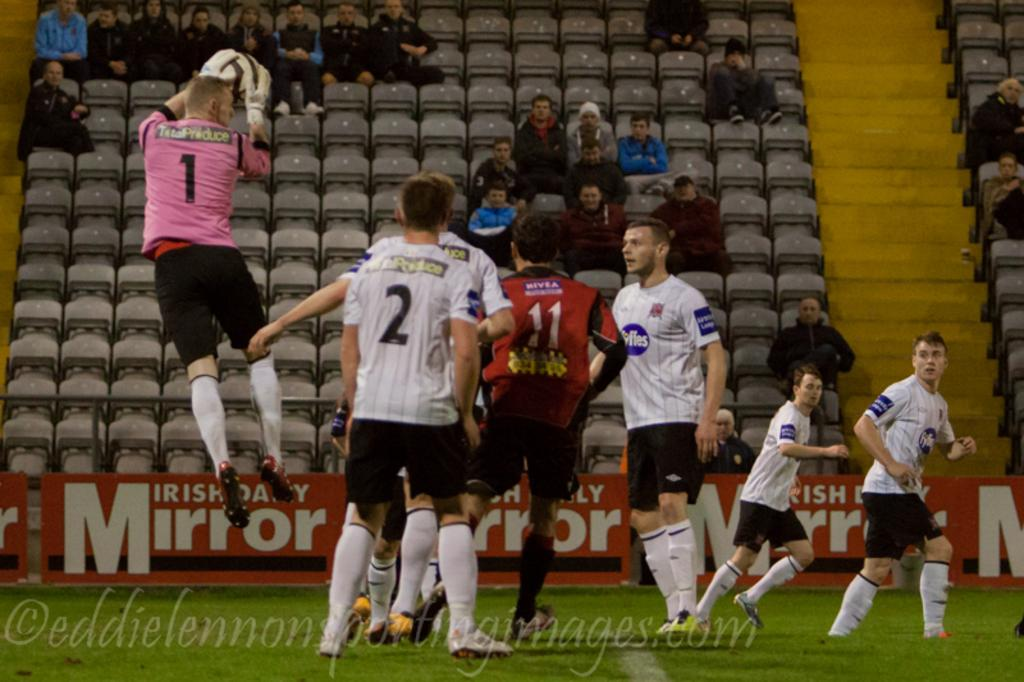<image>
Summarize the visual content of the image. A soccer player wearing a pink shirt with the number one on it is jumping into the air. 